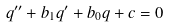Convert formula to latex. <formula><loc_0><loc_0><loc_500><loc_500>q ^ { \prime \prime } + b _ { 1 } q ^ { \prime } + b _ { 0 } q + c = 0</formula> 